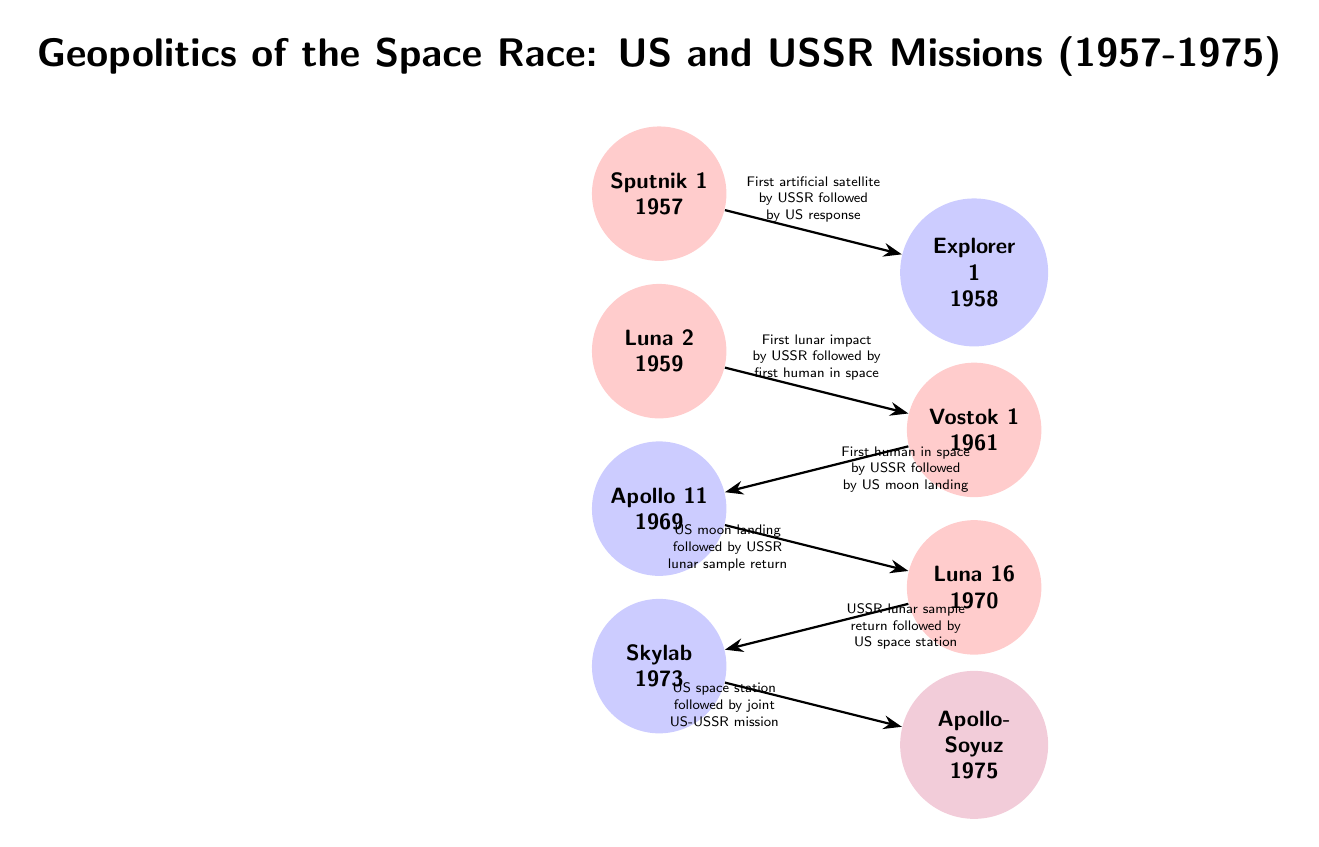What was the first mission by the USSR? The first mission by the USSR listed in the diagram is Sputnik 1 in 1957, which is positioned at the top of the timeline, representing the initial event in the Space Race.
Answer: Sputnik 1 Which event follows Explorer 1? According to the diagram, Explorer 1 (1958) is followed by Luna 2 (1959), which is shown connected by an arrow indicating the sequence of events.
Answer: Luna 2 How many total missions are presented in the diagram? By counting the circular nodes in the diagram, there are a total of seven missions listed (Sputnik 1, Explorer 1, Luna 2, Vostok 1, Apollo 11, Luna 16, Skylab, Apollo-Soyuz).
Answer: 8 What mission follows Apollo 11? The diagram shows that Apollo 11 (1969) is followed by Luna 16 (1970), indicated by the connecting arrow which highlights the chronological relationship.
Answer: Luna 16 What year was the joint mission Apollo-Soyuz? The diagram indicates that the Apollo-Soyuz mission occurred in 1975, as that date is displayed within the event's circular node at the bottom of the timeline.
Answer: 1975 Which mission was the first lunar impact? The first lunar impact mission noted in the diagram is Luna 2, which is explicitly labeled with the year 1959, making it clear that it occurred shortly after Sputnik 1.
Answer: Luna 2 What event resulted in the first human in space? According to the diagram, Vostok 1, which took place in 1961, is the event that resulted in the first human in space, as illustrated next to the corresponding node.
Answer: Vostok 1 What mission is linked to Skylab, and why is it significant? Skylab (1973) is linked to Luna 16 (1970), showing the progression of achievements in space and representing the US's pursuit of a space station following lunar sample returns from the USSR.
Answer: Skylab What follows the US space station initiative? The diagram indicates that following Skylab (1973), the next event is the joint US-USSR mission Apollo-Soyuz (1975), signifying collaboration between the two nations in space exploration.
Answer: Apollo-Soyuz 